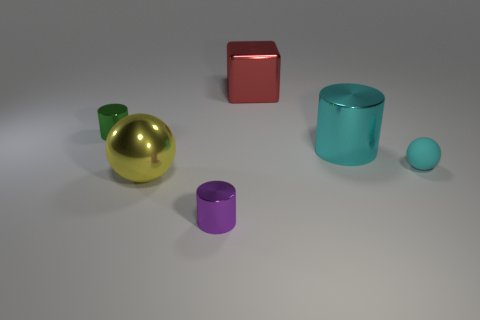Subtract all large cylinders. How many cylinders are left? 2 Subtract all green cylinders. How many cylinders are left? 2 Add 3 small green metal objects. How many objects exist? 9 Subtract all cubes. How many objects are left? 5 Add 5 big cylinders. How many big cylinders are left? 6 Add 1 matte objects. How many matte objects exist? 2 Subtract 1 red cubes. How many objects are left? 5 Subtract all red cylinders. Subtract all red blocks. How many cylinders are left? 3 Subtract all shiny things. Subtract all tiny green metallic things. How many objects are left? 0 